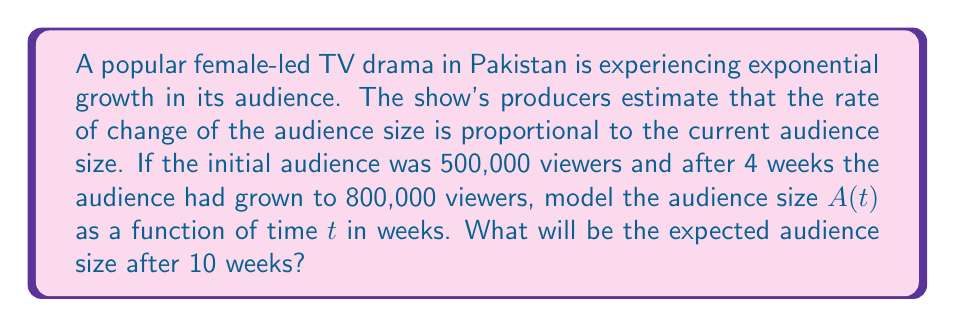Can you solve this math problem? Let's approach this step-by-step:

1) The given information suggests an exponential growth model. We can express this as a differential equation:

   $$\frac{dA}{dt} = kA$$

   where $k$ is the growth constant and $A$ is the audience size.

2) The general solution to this differential equation is:

   $$A(t) = A_0e^{kt}$$

   where $A_0$ is the initial audience size.

3) We know that $A_0 = 500,000$ and we need to find $k$.

4) Using the information that after 4 weeks, the audience is 800,000:

   $$800,000 = 500,000e^{4k}$$

5) Solving for $k$:

   $$e^{4k} = \frac{800,000}{500,000} = 1.6$$
   $$4k = \ln(1.6)$$
   $$k = \frac{\ln(1.6)}{4} \approx 0.1178$$

6) Now we have our complete model:

   $$A(t) = 500,000e^{0.1178t}$$

7) To find the audience after 10 weeks, we substitute $t = 10$:

   $$A(10) = 500,000e^{0.1178 \cdot 10} \approx 1,613,706$$
Answer: The expected audience size after 10 weeks will be approximately 1,613,706 viewers. 